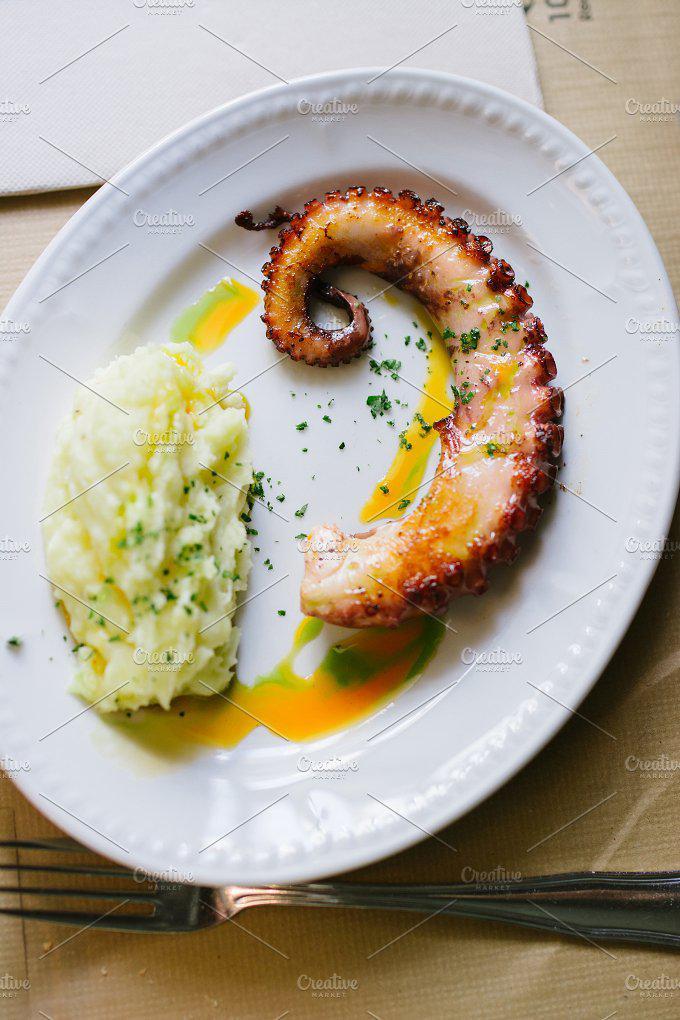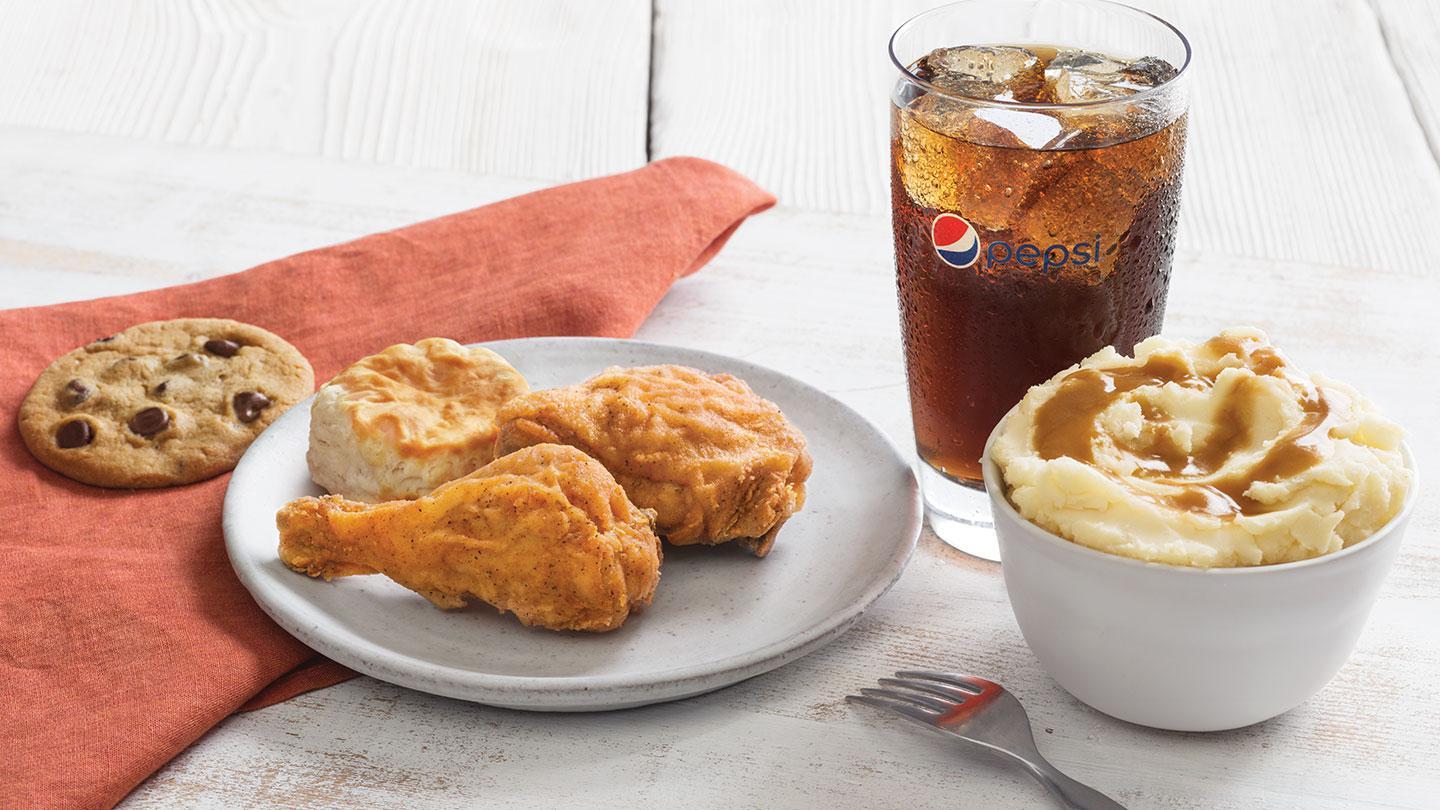The first image is the image on the left, the second image is the image on the right. Assess this claim about the two images: "A spoon sits by the food in one of the images.". Correct or not? Answer yes or no. No. The first image is the image on the left, the second image is the image on the right. Examine the images to the left and right. Is the description "Right image shows a round solid-colored dish containing some type of meat item." accurate? Answer yes or no. Yes. 